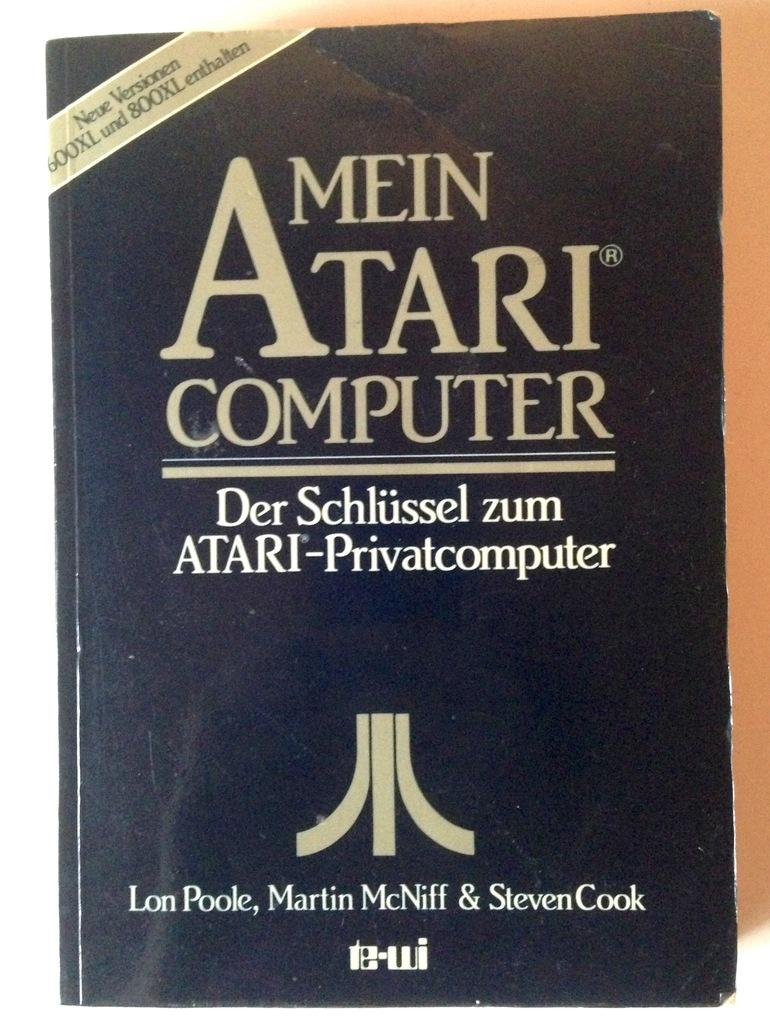<image>
Summarize the visual content of the image. The front cover of a German book the cover of which translates to My Atari Computer has no images on the front. 